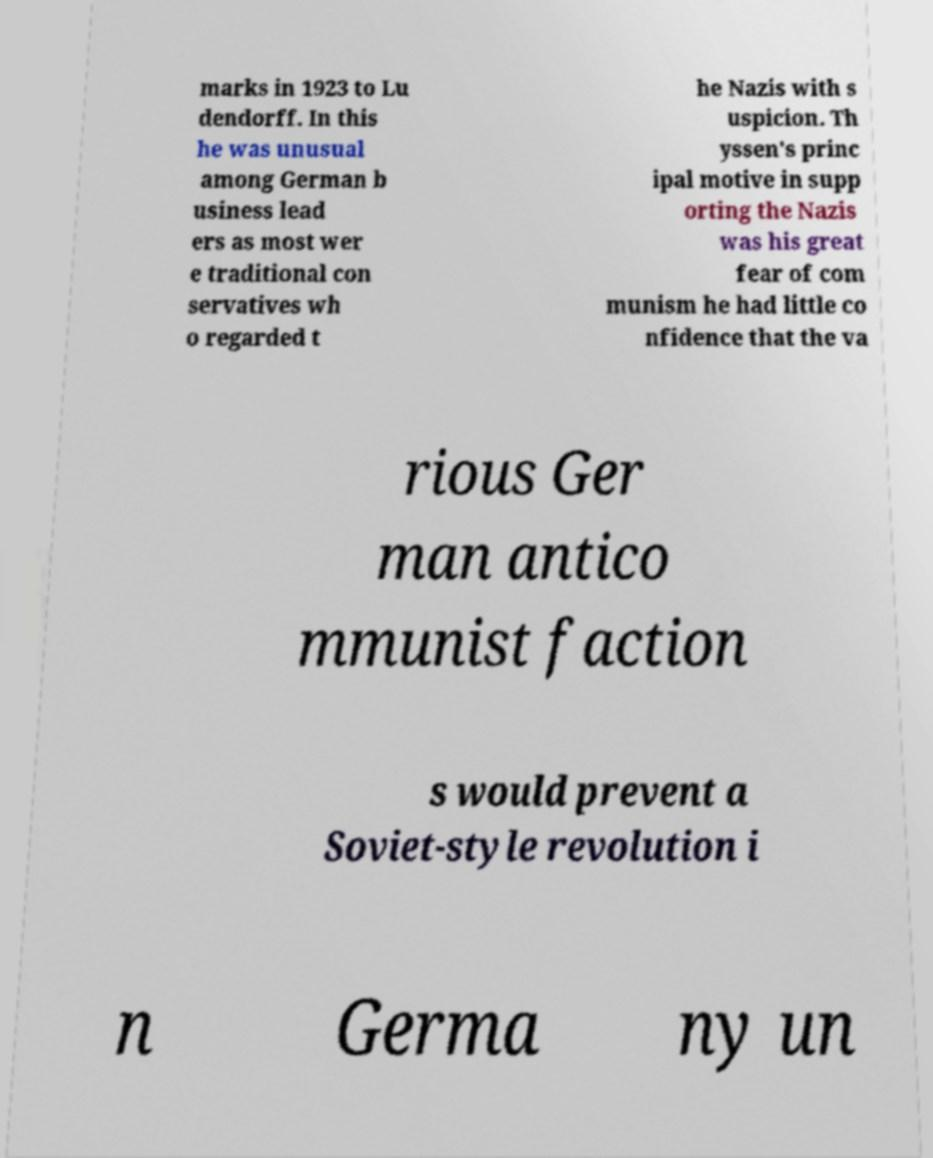Please identify and transcribe the text found in this image. marks in 1923 to Lu dendorff. In this he was unusual among German b usiness lead ers as most wer e traditional con servatives wh o regarded t he Nazis with s uspicion. Th yssen's princ ipal motive in supp orting the Nazis was his great fear of com munism he had little co nfidence that the va rious Ger man antico mmunist faction s would prevent a Soviet-style revolution i n Germa ny un 